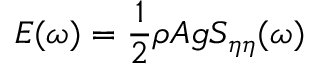<formula> <loc_0><loc_0><loc_500><loc_500>E ( \omega ) = \frac { 1 } { 2 } \rho A g S _ { \eta \eta } ( \omega )</formula> 